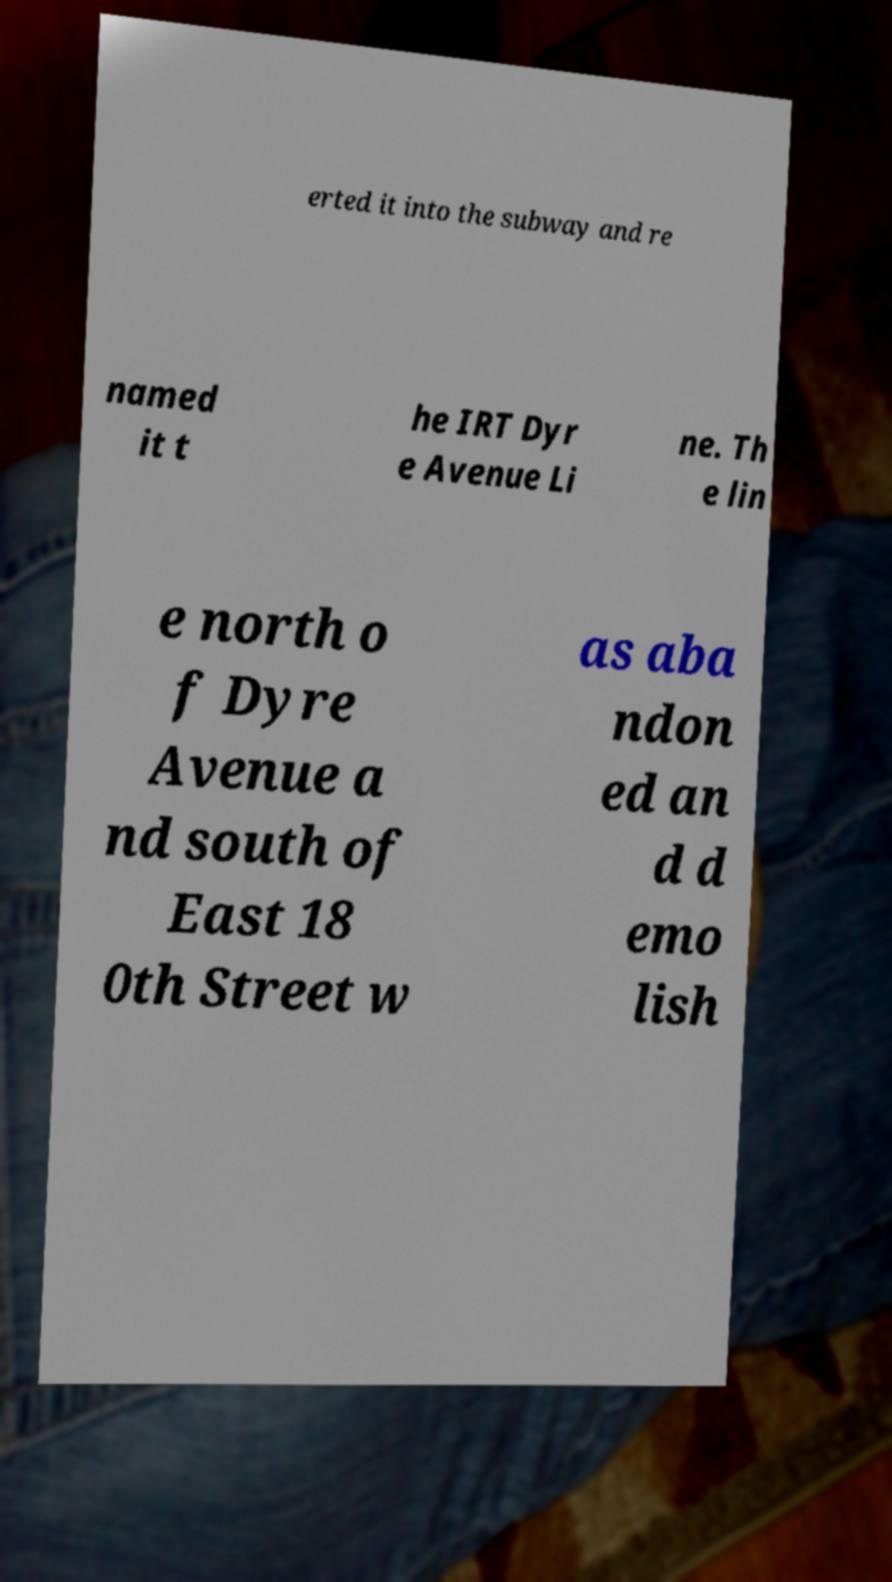Please identify and transcribe the text found in this image. erted it into the subway and re named it t he IRT Dyr e Avenue Li ne. Th e lin e north o f Dyre Avenue a nd south of East 18 0th Street w as aba ndon ed an d d emo lish 